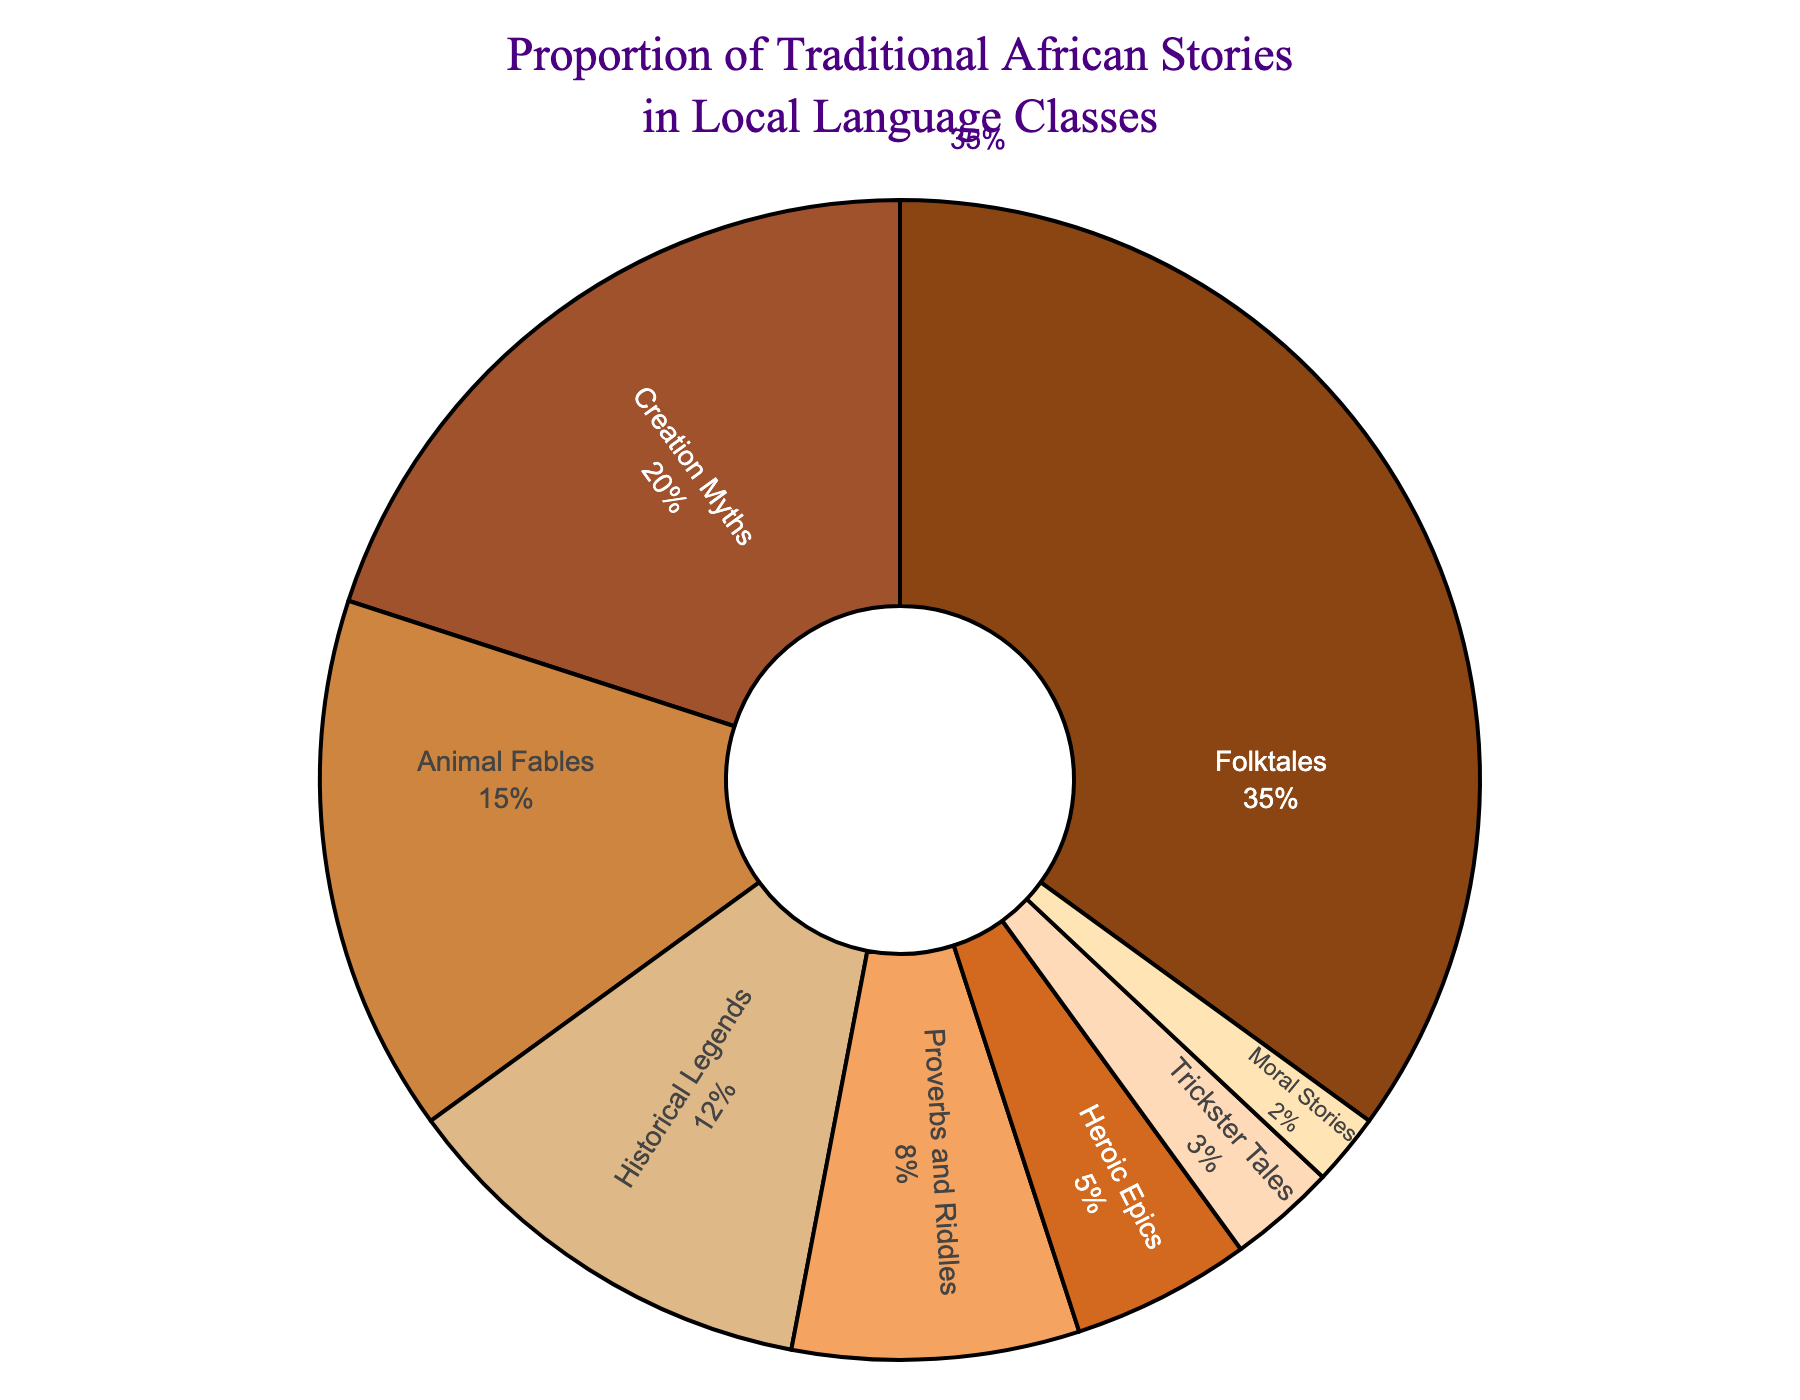What is the most frequently taught type of traditional African story in local language classes? The segment representing "Folktales" holds the largest percentage, which is visually the biggest slice of the pie chart. Hence, it is the most frequently taught type.
Answer: Folktales How many different types of stories together amount to more than half of the total percentage? Adding the percentages of Folktales (35%), Creation Myths (20%), and Animal Fables (15%) equals 70%, which is more than half. Thus, there are 3 types.
Answer: 3 What is the total percentage of Historical Legends and Heroic Epics combined? The percentages for Historical Legends and Heroic Epics are 12% and 5%, respectively. Adding them together gives 12% + 5% = 17%.
Answer: 17% Which type of story is taught less frequently than Proverbs and Riddles but more frequently than Moral Stories? Proverbs and Riddles are at 8%, and Moral Stories are at 2%. Trickster Tales fall between these two percentages, at 3%.
Answer: Trickster Tales What is the difference in the percentage between Folktales and Creation Myths? Folktales account for 35%, while Creation Myths account for 20%. The difference is 35% - 20% = 15%.
Answer: 15% If you combine the percentages of Animal Fables, Historical Legends, and Heroic Epics, will they surpass the percentage of Folktales? Adding the percentages of Animal Fables (15%), Historical Legends (12%), and Heroic Epics (5%) gives 15% + 12% + 5% = 32%, which is less than Folktales' 35%.
Answer: No Which story type is represented by the color closest to golden brown? The color closest to golden brown in the chart represents "Creation Myths," with a percentage of 20%.
Answer: Creation Myths Rank the story types starting from the most frequently taught to the least. The visual sizes and percentages from the chart provide the ranking: Folktales (35%), Creation Myths (20%), Animal Fables (15%), Historical Legends (12%), Proverbs and Riddles (8%), Heroic Epics (5%), Trickster Tales (3%), Moral Stories (2%).
Answer: Folktales > Creation Myths > Animal Fables > Historical Legends > Proverbs and Riddles > Heroic Epics > Trickster Tales > Moral Stories 